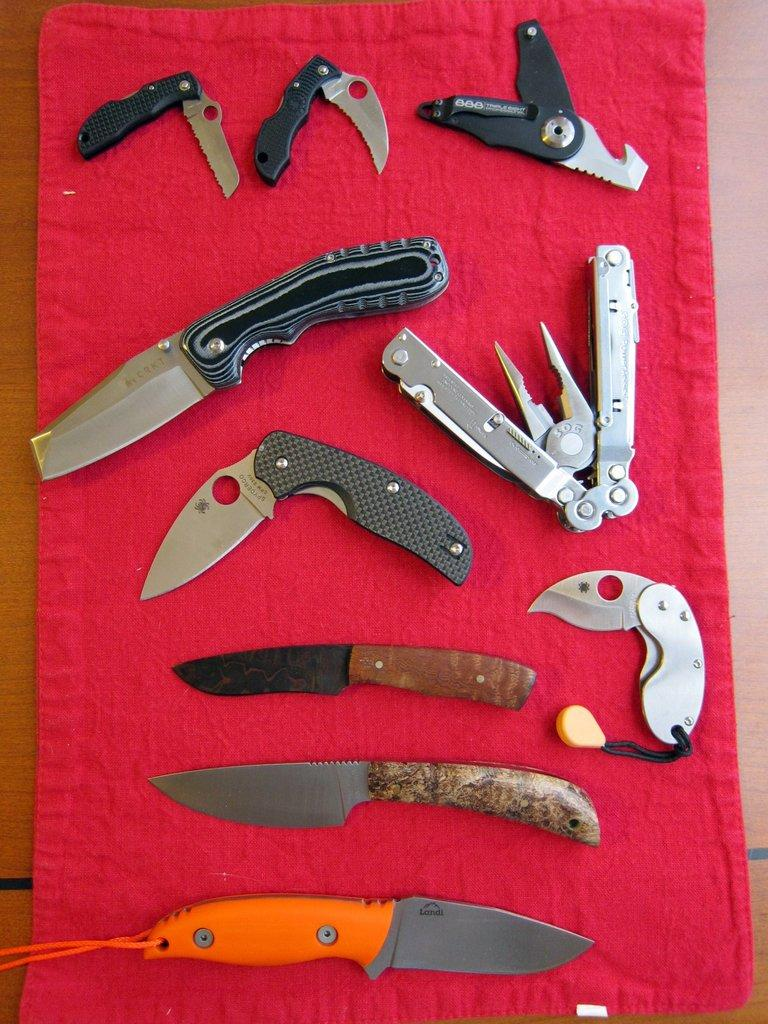What type of objects are in the image? There are different knives in the image. Where are the knives located? The knives are on a table. What type of mist can be seen surrounding the knives in the image? There is no mist present in the image; it only features different knives on a table. 